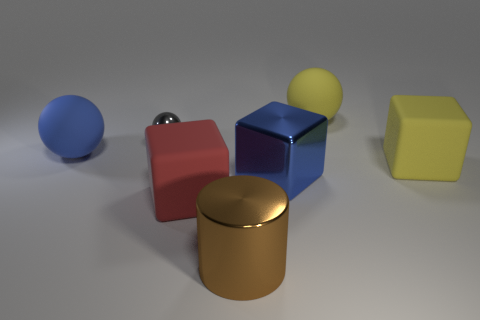The small shiny thing is what color?
Give a very brief answer. Gray. There is a matte ball that is right of the cylinder; how many brown things are right of it?
Ensure brevity in your answer.  0. Are there any big cylinders that are right of the large blue object that is to the left of the metallic cylinder?
Ensure brevity in your answer.  Yes. Are there any matte spheres right of the large brown metal thing?
Make the answer very short. Yes. Do the blue object that is in front of the blue sphere and the brown metal thing have the same shape?
Offer a terse response. No. How many red matte objects have the same shape as the big brown metal thing?
Offer a very short reply. 0. Is there a ball made of the same material as the red thing?
Provide a succinct answer. Yes. There is a large cube that is to the right of the big ball behind the large blue matte ball; what is it made of?
Give a very brief answer. Rubber. What is the size of the metal thing that is right of the brown shiny thing?
Your answer should be very brief. Large. There is a cylinder; is it the same color as the big ball that is to the right of the small gray metallic ball?
Give a very brief answer. No. 